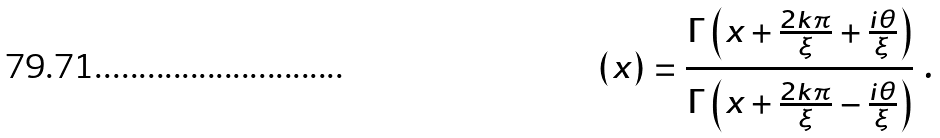Convert formula to latex. <formula><loc_0><loc_0><loc_500><loc_500>\left ( x \right ) = \frac { \Gamma \left ( x + \frac { 2 k \pi } { \xi } + \frac { i \theta } { \xi } \right ) } { \Gamma \left ( x + \frac { 2 k \pi } { \xi } - \frac { i \theta } { \xi } \right ) } \ .</formula> 